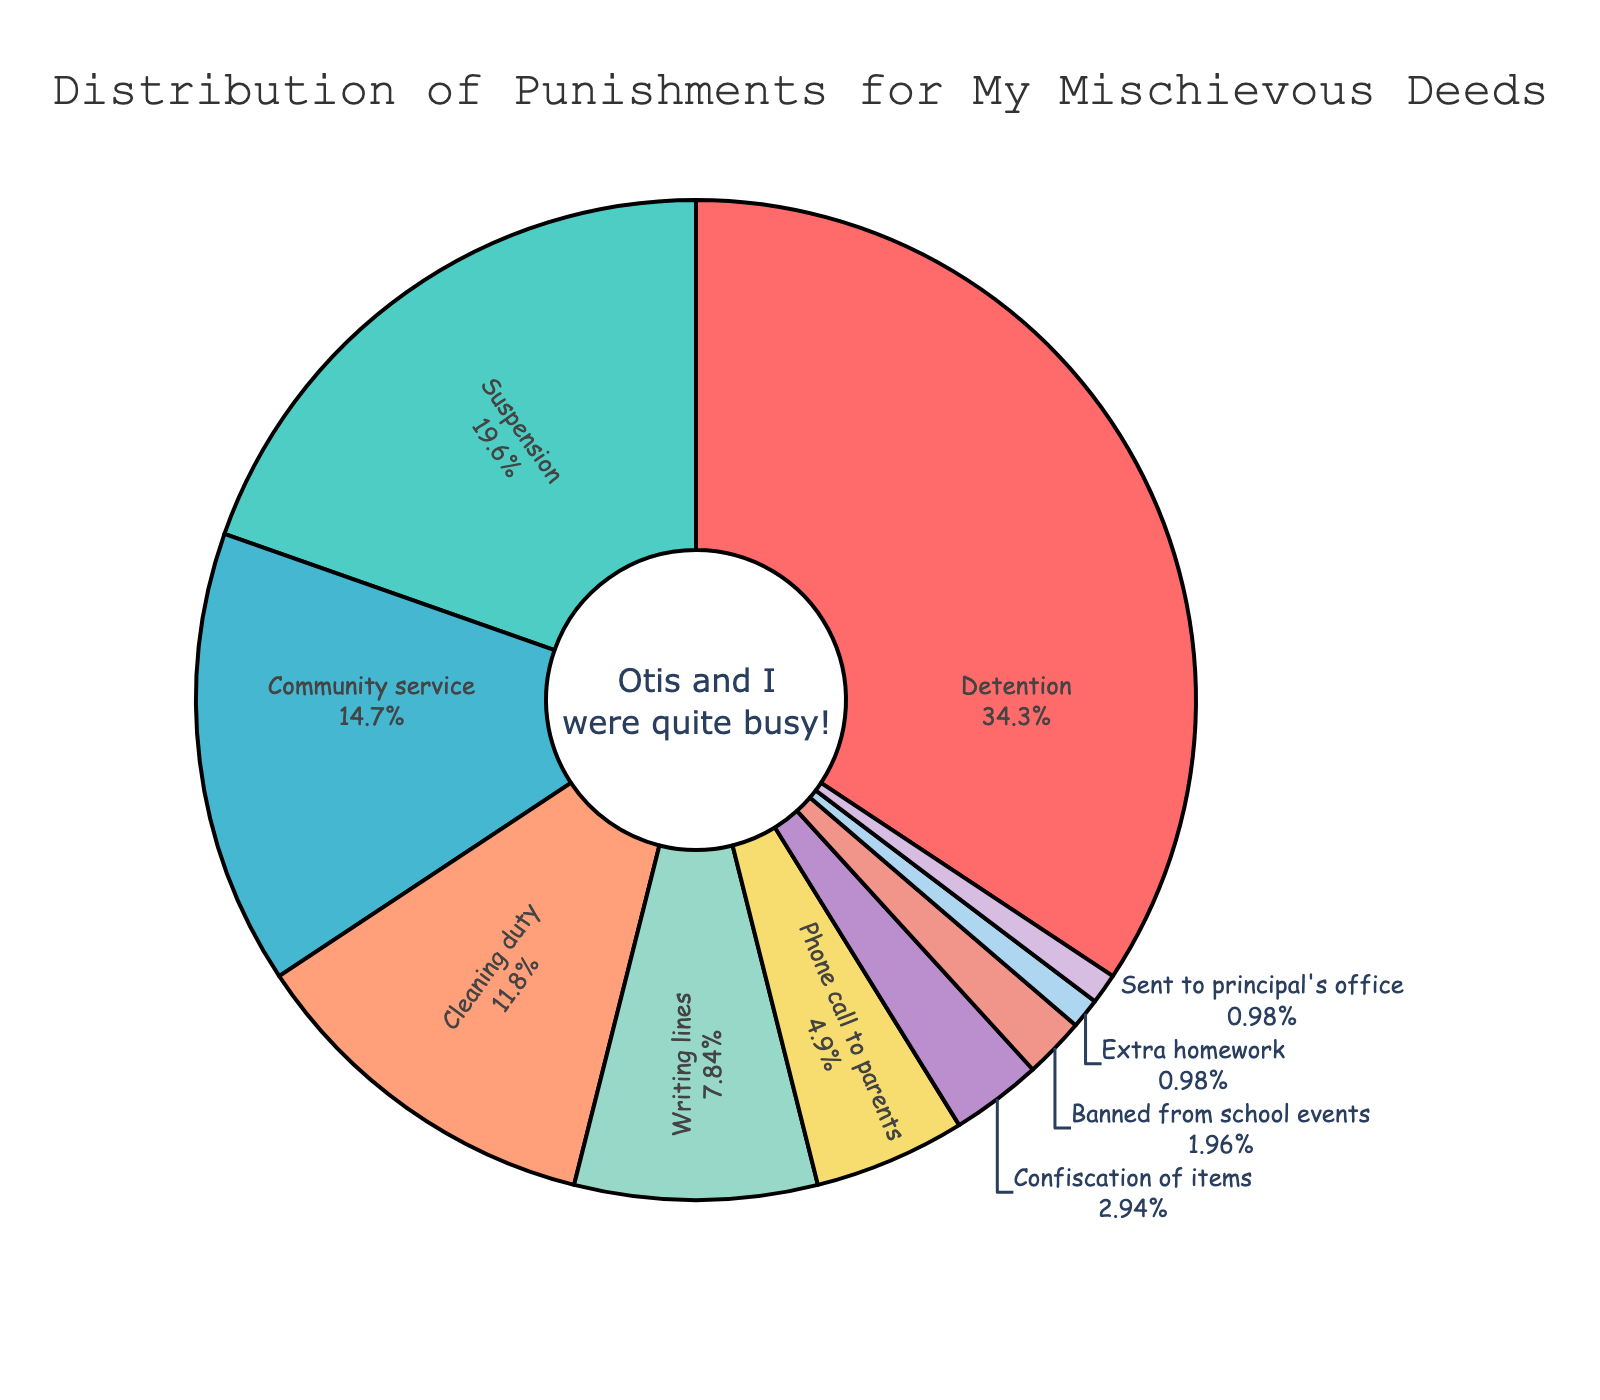What punishment was received most frequently? The punishment with the highest percentage is most frequent. Detention has 35%.
Answer: Detention How much more frequent is suspension compared to writing lines? Find the percentages for both: Suspension is 20% and writing lines is 8%. Subtracting 8% from 20% gives the difference.
Answer: 12% Which punishments collectively make up half of the total punishments? Starting from the highest percentage, add the percentages until they reach or exceed 50%. Detention (35%) + Suspension (20%) = 55%.
Answer: Detention and Suspension What is the total percentage of punishments that involve some form of school duty (cleaning duty and community service)? Sum the percentages of community service (15%) and cleaning duty (12%).
Answer: 27% Compare the frequency of cleaning duty and confiscation of items. Which is more common and by how much? Cleaning duty is 12% and confiscation of items is 3%. Subtract 3% from 12%.
Answer: Cleaning duty by 9% Are there any punishments that have the same frequency? Check the percentages of each punishment. Extra homework and sent to principal's office both have 1%.
Answer: Extra homework and Sent to principal's office What percentage of punishments is received through school-related activities (like banning from school events or extra homework)? Sum the percentages of banned from school events (2%) and extra homework (1%).
Answer: 3% If a student wanted to avoid the most common punishment, by what percentage would their chances decrease if they aimed for the second most common punishment only? The most common punishment (Detention) is 35%, and the second most common (Suspension) is 20%. Subtract 20% from 35%.
Answer: 15% What is the percentage difference between the least frequent and most frequent punishments? The least frequent (tied between extra homework and sent to principal's office) are both 1%, and the most frequent (Detention) is 35%. Subtract 1% from 35%.
Answer: 34% How many punishments have a frequency lower than 10%? Identify and count the percentages lower than 10%: writing lines (8%), phone call to parents (5%), confiscation of items (3%), banned from school events (2%), extra homework (1%), and sent to principal’s office (1%). There are 6 punishments.
Answer: 6 